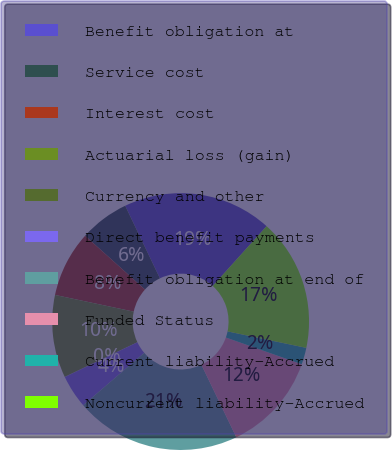Convert chart to OTSL. <chart><loc_0><loc_0><loc_500><loc_500><pie_chart><fcel>Benefit obligation at<fcel>Service cost<fcel>Interest cost<fcel>Actuarial loss (gain)<fcel>Currency and other<fcel>Direct benefit payments<fcel>Benefit obligation at end of<fcel>Funded Status<fcel>Current liability-Accrued<fcel>Noncurrent liability-Accrued<nl><fcel>18.78%<fcel>6.25%<fcel>8.32%<fcel>10.4%<fcel>0.04%<fcel>4.18%<fcel>20.85%<fcel>12.47%<fcel>2.11%<fcel>16.61%<nl></chart> 